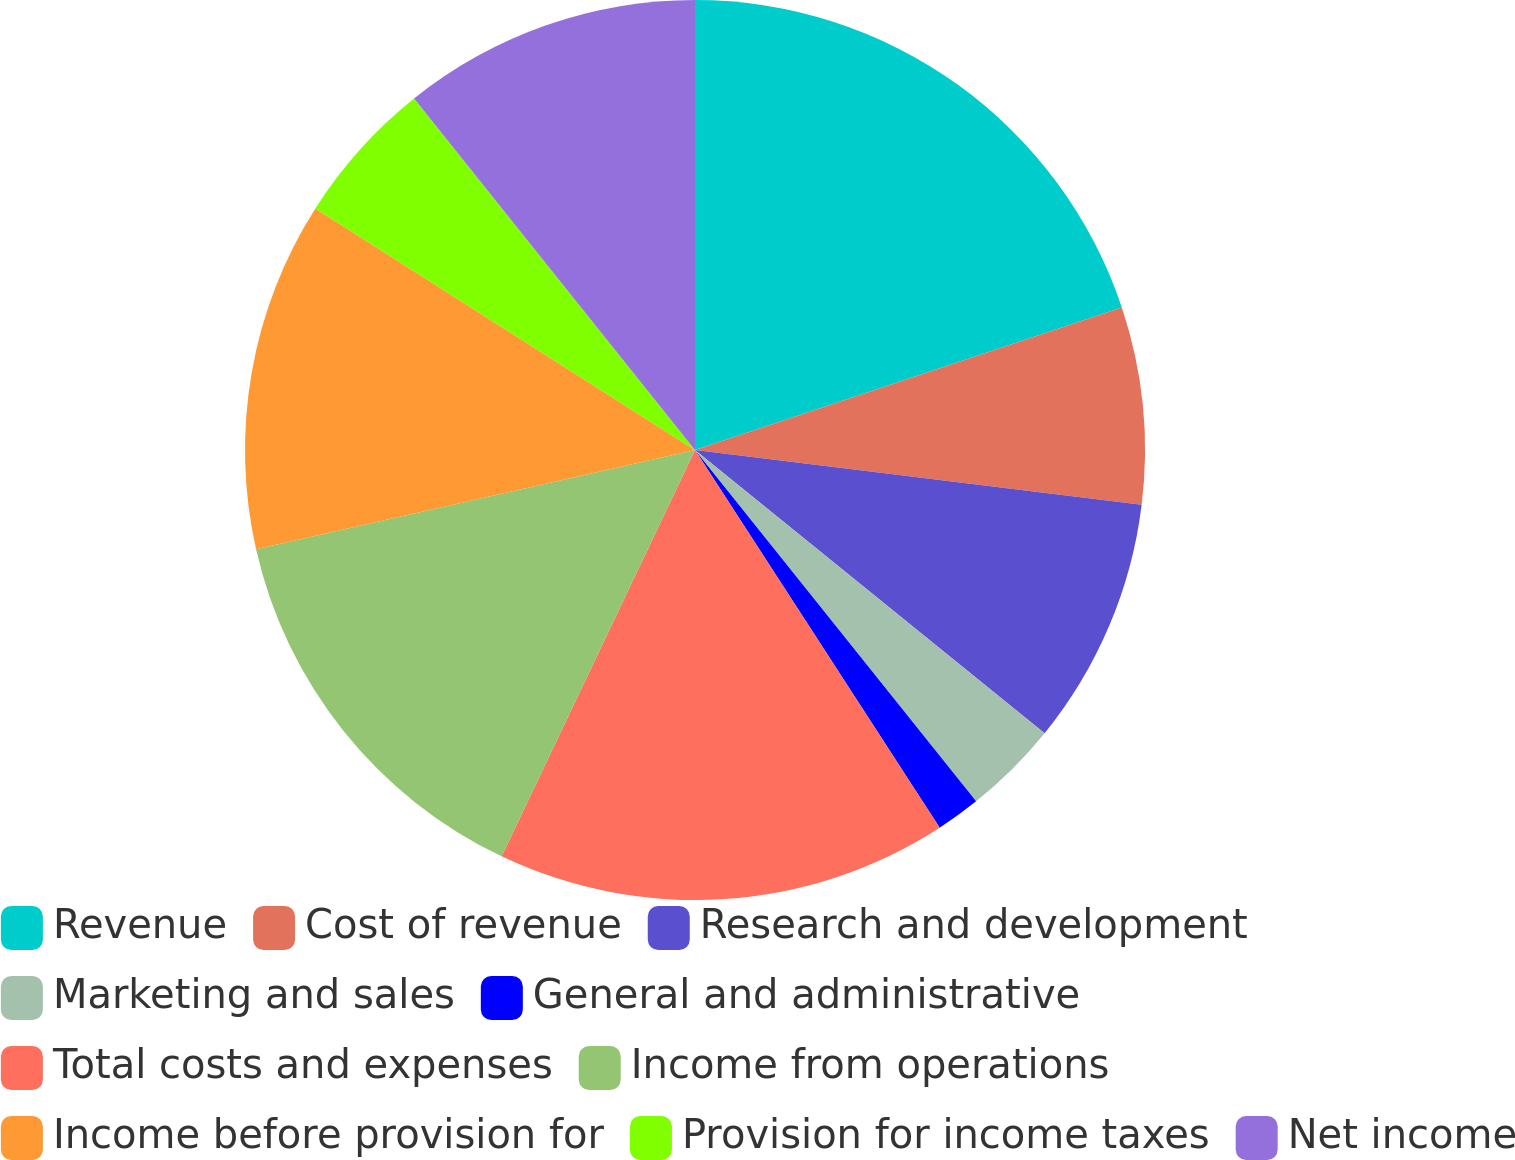Convert chart. <chart><loc_0><loc_0><loc_500><loc_500><pie_chart><fcel>Revenue<fcel>Cost of revenue<fcel>Research and development<fcel>Marketing and sales<fcel>General and administrative<fcel>Total costs and expenses<fcel>Income from operations<fcel>Income before provision for<fcel>Provision for income taxes<fcel>Net income<nl><fcel>19.87%<fcel>7.07%<fcel>8.9%<fcel>3.42%<fcel>1.59%<fcel>16.22%<fcel>14.39%<fcel>12.56%<fcel>5.25%<fcel>10.73%<nl></chart> 